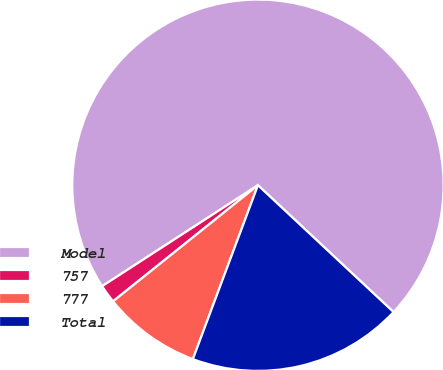Convert chart to OTSL. <chart><loc_0><loc_0><loc_500><loc_500><pie_chart><fcel>Model<fcel>757<fcel>777<fcel>Total<nl><fcel>71.12%<fcel>1.6%<fcel>8.55%<fcel>18.73%<nl></chart> 